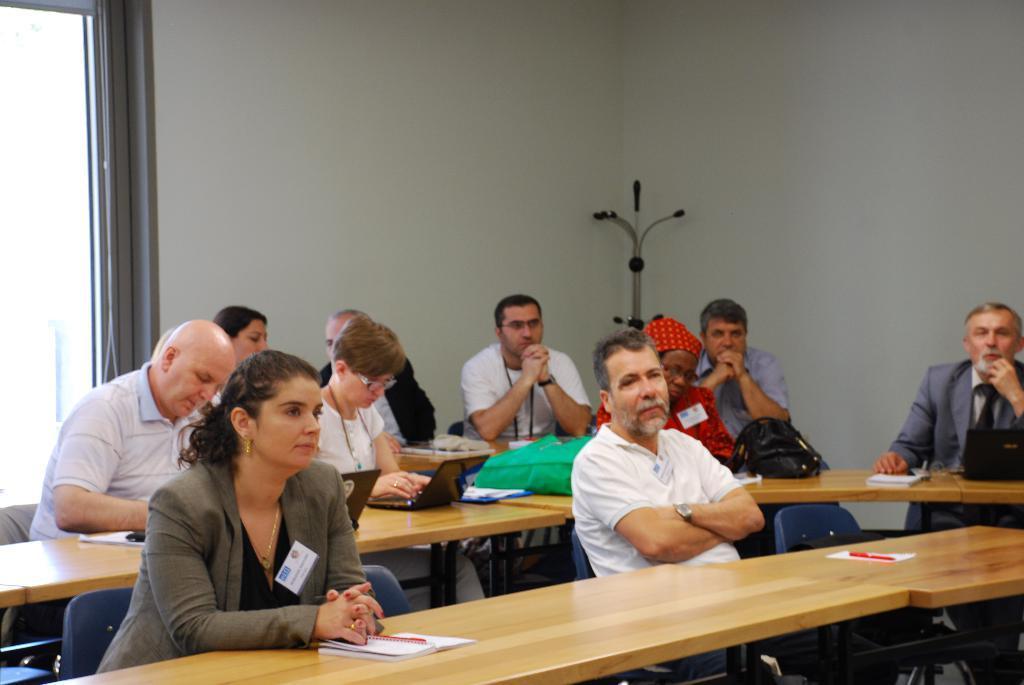Describe this image in one or two sentences. It is looks like a classroom. There are few peoples are sat on the chair. There are benches. Here we can see laptop, book, pen and backpack here. There is a white color wall. In middle, there is a rod. Left side, we can see glass window. 